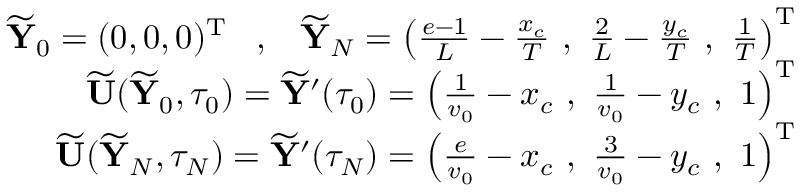Convert formula to latex. <formula><loc_0><loc_0><loc_500><loc_500>\begin{array} { r } { \widetilde { \mathbf Y } _ { 0 } = ( 0 , 0 , 0 ) ^ { \mathrm T } \, , \, \widetilde { \mathbf Y } _ { N } = \left ( \frac { e - 1 } { L } - \frac { x _ { c } } { T } \, , \, \frac { 2 } { L } - \frac { y _ { c } } { T } \, , \, \frac { 1 } { T } \right ) ^ { \mathrm T } } \\ { \widetilde { \mathbf U } ( \widetilde { \mathbf Y } _ { 0 } , \tau _ { 0 } ) = \widetilde { \mathbf Y } ^ { \prime } ( \tau _ { 0 } ) = \left ( \frac { 1 } { v _ { 0 } } - x _ { c } \, , \, \frac { 1 } { v _ { 0 } } - y _ { c } \, , \, 1 \right ) ^ { \mathrm T } } \\ { \widetilde { \mathbf U } ( \widetilde { \mathbf Y } _ { N } , \tau _ { N } ) = \widetilde { \mathbf Y } ^ { \prime } ( \tau _ { N } ) = \left ( \frac { e } { v _ { 0 } } - x _ { c } \, , \, \frac { 3 } { v _ { 0 } } - y _ { c } \, , \, 1 \right ) ^ { \mathrm T } } \end{array}</formula> 